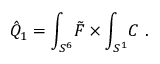Convert formula to latex. <formula><loc_0><loc_0><loc_500><loc_500>\hat { Q } _ { 1 } = \int _ { S ^ { 6 } } \, \tilde { F } \times \int _ { S ^ { 1 } } \, C \ .</formula> 